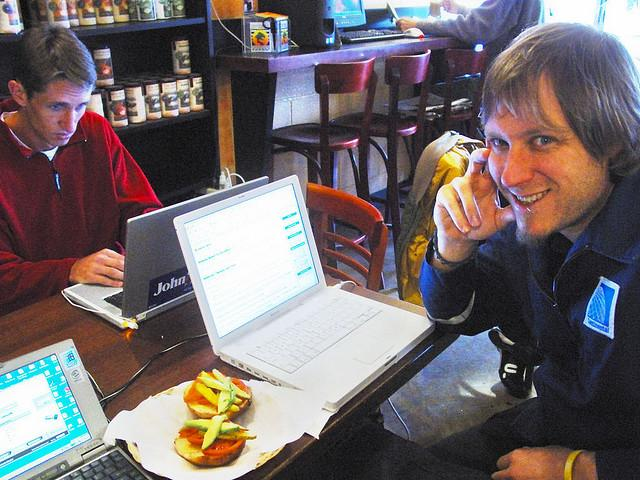What are the green items on top of the tomatoes on the man's sandwich? Please explain your reasoning. avocados. The items on top of the tomatoes have a green and yellow coloring.  also they appear to be relatively soft.  these all point to the item being a favorite topping or avocados. 